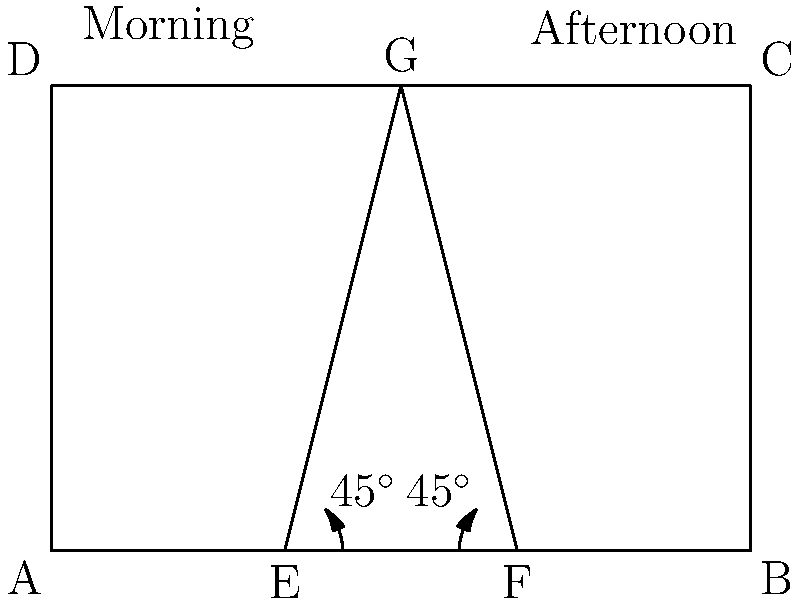Your barn has two windows on the south-facing wall for optimal sunlight exposure to your indoor herb garden. The morning sun enters through the left window at a 45° angle, while the afternoon sun enters through the right window at the same angle. If the barn wall is 6 meters wide and 4 meters high, and the windows are placed 2 meters from each end of the wall, what is the total area (in square meters) of the barn floor that receives direct sunlight throughout the day? Let's approach this step-by-step:

1) First, we need to calculate the area of sunlight from each window separately.

2) For each window, the sunlight forms a right-angled triangle on the barn floor.

3) We know that the angle of sunlight is 45° for both windows, and the height of the wall is 4 meters.

4) In a 45-45-90 triangle, the two legs are equal. So the base of each triangle on the floor will also be 4 meters.

5) The area of a triangle is given by the formula: $A = \frac{1}{2} \times base \times height$

6) For each triangle: $A = \frac{1}{2} \times 4 \times 4 = 8$ square meters

7) Since there are two windows, the total area is: $8 + 8 = 16$ square meters

However, we need to consider if these areas overlap:

8) The distance between the windows is 2 meters (from 2m to 4m on the 6m wall).

9) Each triangle extends 4 meters into the barn, which is more than the 2-meter gap between the windows.

10) This means the triangles will overlap, but the total area receiving sunlight will still be 16 square meters, as the overlapping area is simply lit at different times of the day.
Answer: 16 square meters 